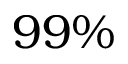<formula> <loc_0><loc_0><loc_500><loc_500>9 9 \%</formula> 